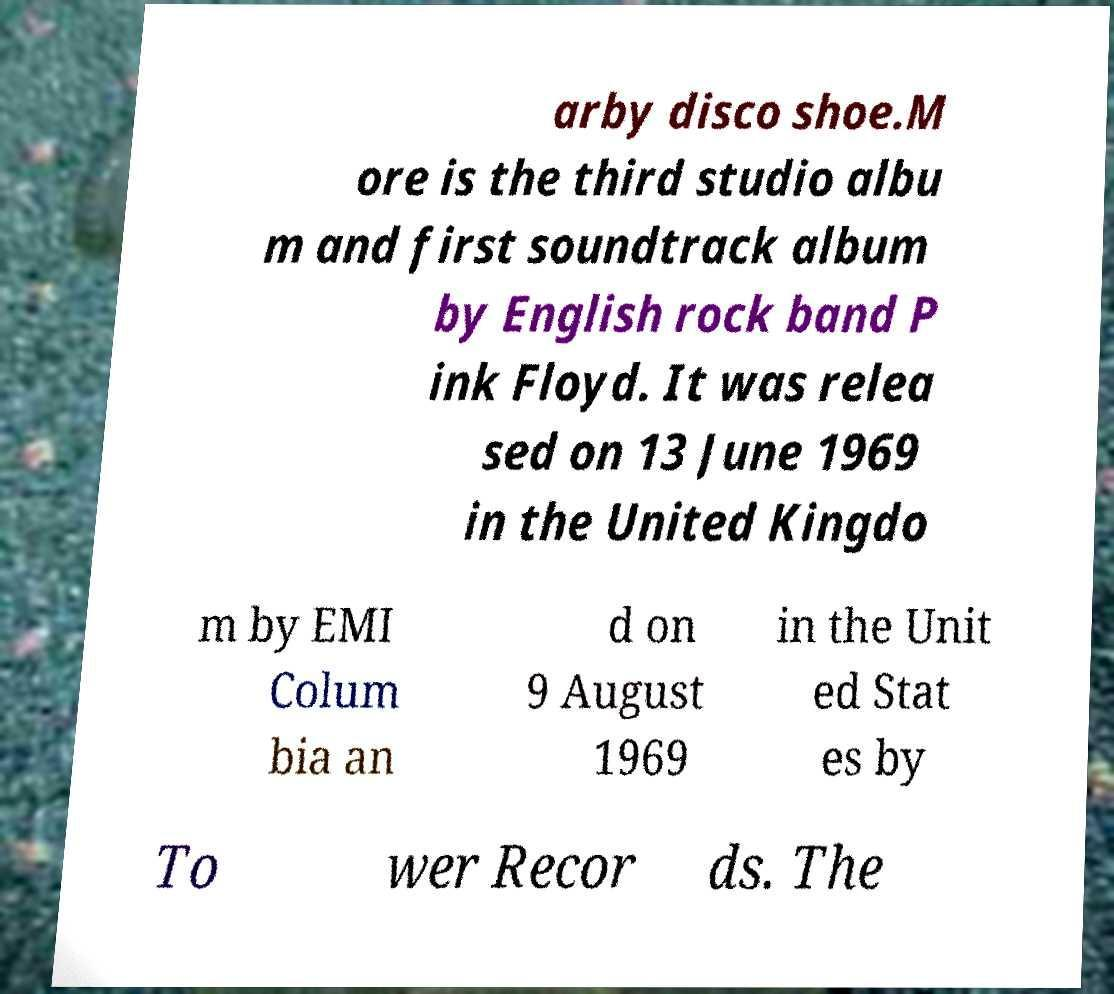For documentation purposes, I need the text within this image transcribed. Could you provide that? arby disco shoe.M ore is the third studio albu m and first soundtrack album by English rock band P ink Floyd. It was relea sed on 13 June 1969 in the United Kingdo m by EMI Colum bia an d on 9 August 1969 in the Unit ed Stat es by To wer Recor ds. The 